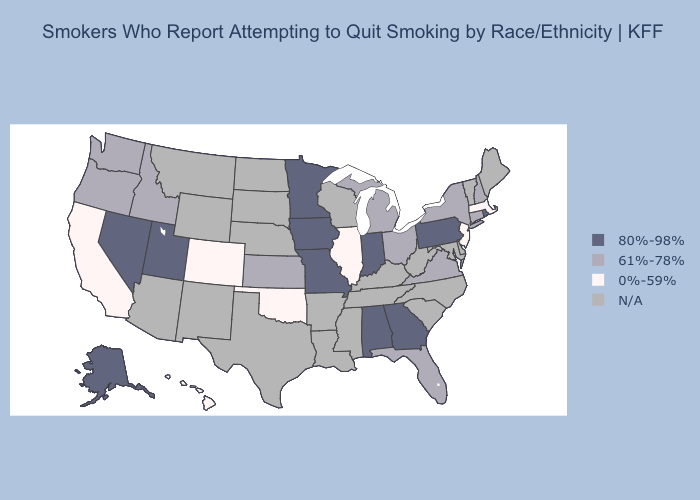Among the states that border Indiana , does Illinois have the highest value?
Answer briefly. No. Does Indiana have the lowest value in the USA?
Keep it brief. No. Which states hav the highest value in the West?
Answer briefly. Alaska, Nevada, Utah. What is the value of South Dakota?
Answer briefly. N/A. What is the highest value in the South ?
Give a very brief answer. 80%-98%. Does the map have missing data?
Write a very short answer. Yes. Name the states that have a value in the range N/A?
Concise answer only. Arizona, Arkansas, Delaware, Kentucky, Louisiana, Maine, Maryland, Mississippi, Montana, Nebraska, New Mexico, North Carolina, North Dakota, South Carolina, South Dakota, Tennessee, Texas, Vermont, West Virginia, Wisconsin, Wyoming. Among the states that border New Mexico , which have the highest value?
Write a very short answer. Utah. What is the value of South Dakota?
Keep it brief. N/A. Name the states that have a value in the range 0%-59%?
Give a very brief answer. California, Colorado, Hawaii, Illinois, Massachusetts, New Jersey, Oklahoma. Name the states that have a value in the range 61%-78%?
Write a very short answer. Connecticut, Florida, Idaho, Kansas, Michigan, New Hampshire, New York, Ohio, Oregon, Virginia, Washington. Name the states that have a value in the range N/A?
Concise answer only. Arizona, Arkansas, Delaware, Kentucky, Louisiana, Maine, Maryland, Mississippi, Montana, Nebraska, New Mexico, North Carolina, North Dakota, South Carolina, South Dakota, Tennessee, Texas, Vermont, West Virginia, Wisconsin, Wyoming. Does California have the highest value in the USA?
Be succinct. No. What is the highest value in the USA?
Concise answer only. 80%-98%. 